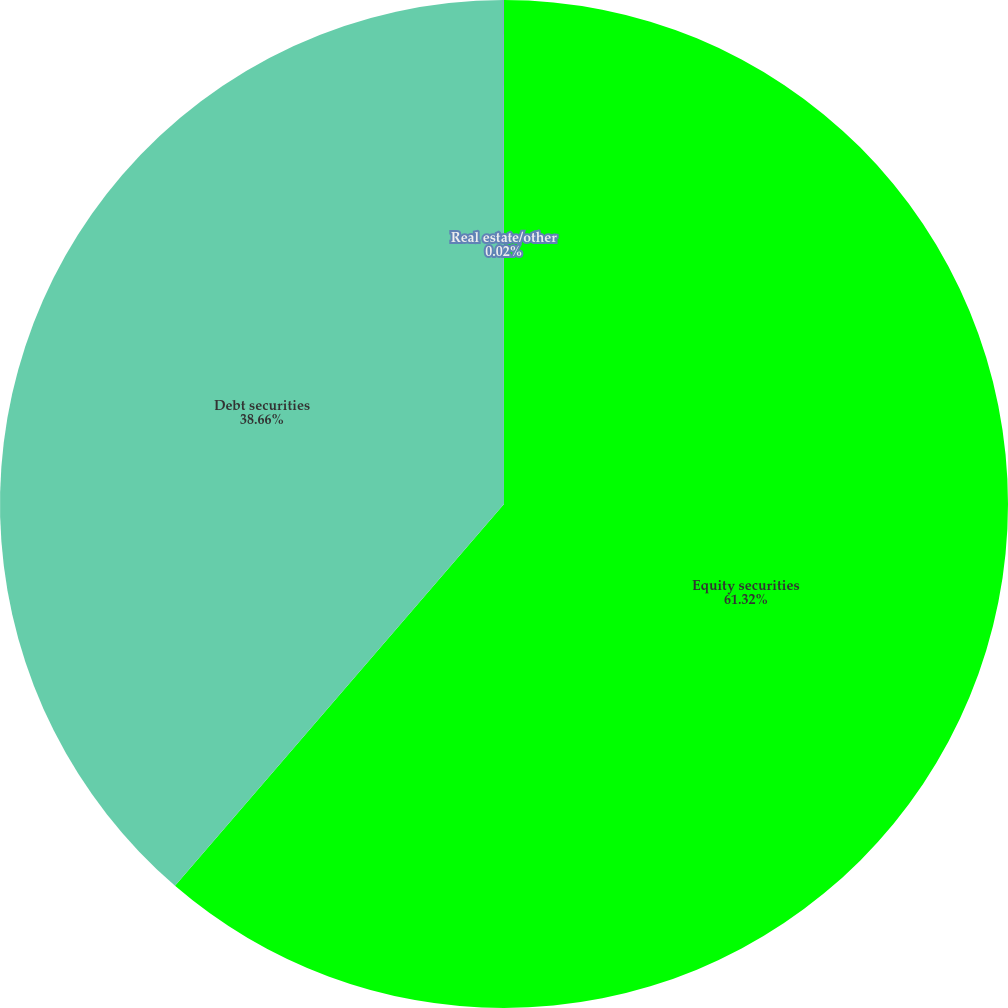<chart> <loc_0><loc_0><loc_500><loc_500><pie_chart><fcel>Equity securities<fcel>Debt securities<fcel>Real estate/other<nl><fcel>61.32%<fcel>38.66%<fcel>0.02%<nl></chart> 